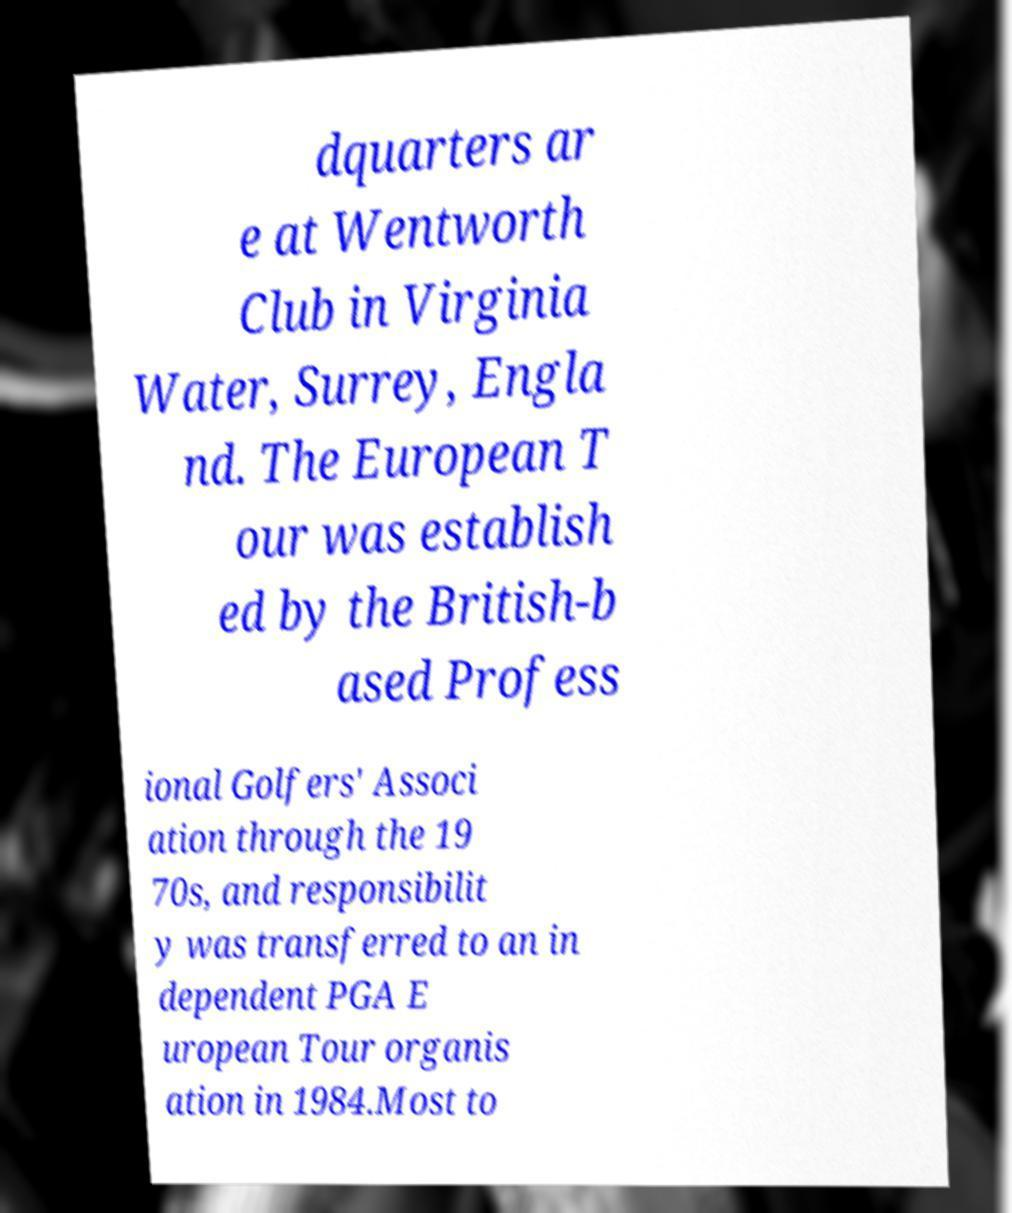There's text embedded in this image that I need extracted. Can you transcribe it verbatim? dquarters ar e at Wentworth Club in Virginia Water, Surrey, Engla nd. The European T our was establish ed by the British-b ased Profess ional Golfers' Associ ation through the 19 70s, and responsibilit y was transferred to an in dependent PGA E uropean Tour organis ation in 1984.Most to 